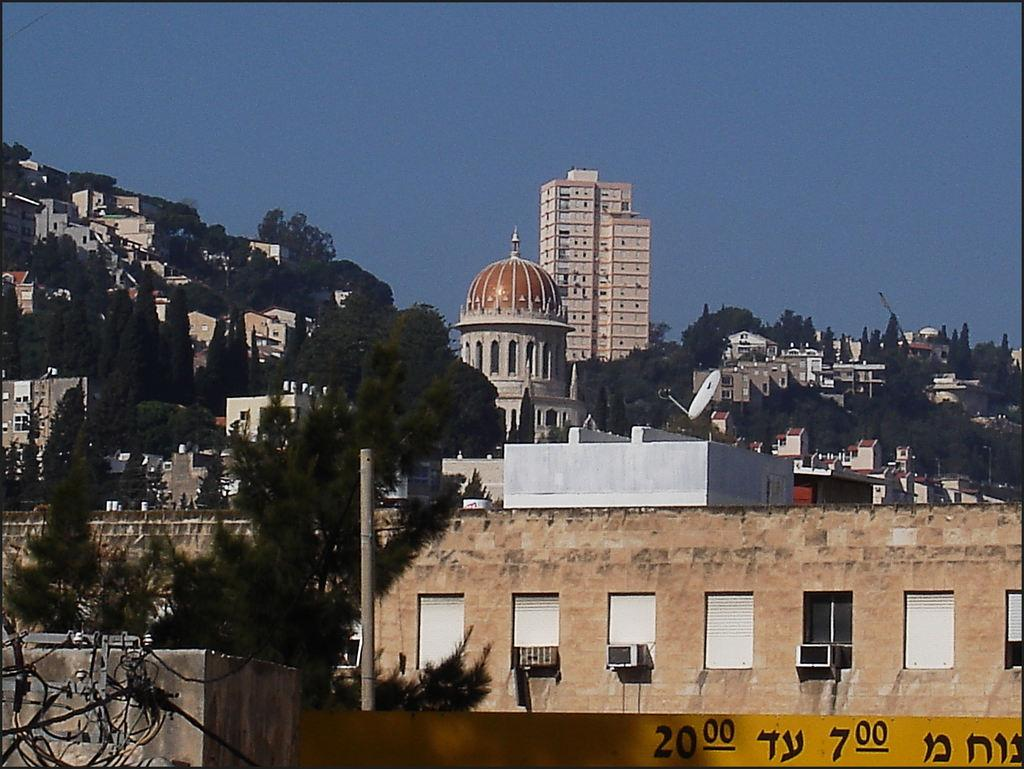What types of structures are visible in the image? There are buildings and houses in the image. What natural elements can be seen in the image? There are trees in the image. What architectural features are present in the image? There are walls and windows in the image. What is the condition of the sky in the background of the image? The sky is clear in the background of the image. What other object can be seen in the image? There is a pole in the image. Can you tell me how many rings are hanging from the pole in the image? There are no rings present on the pole in the image. What type of bone is visible in the image? There is no bone present in the image. 